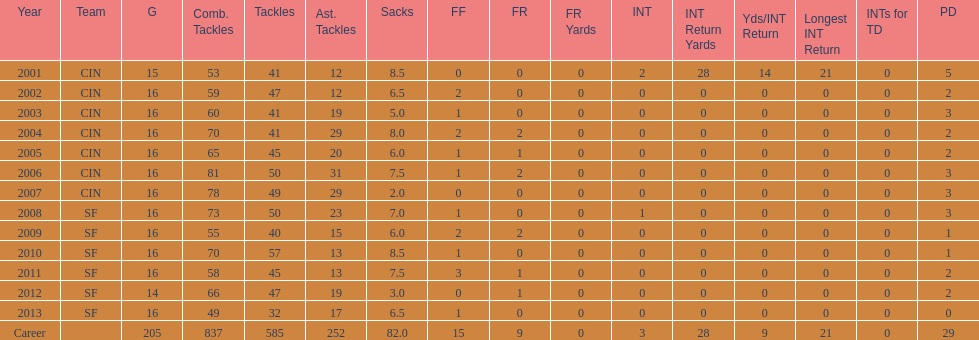How many sacks did this player have in his first five seasons? 34. 